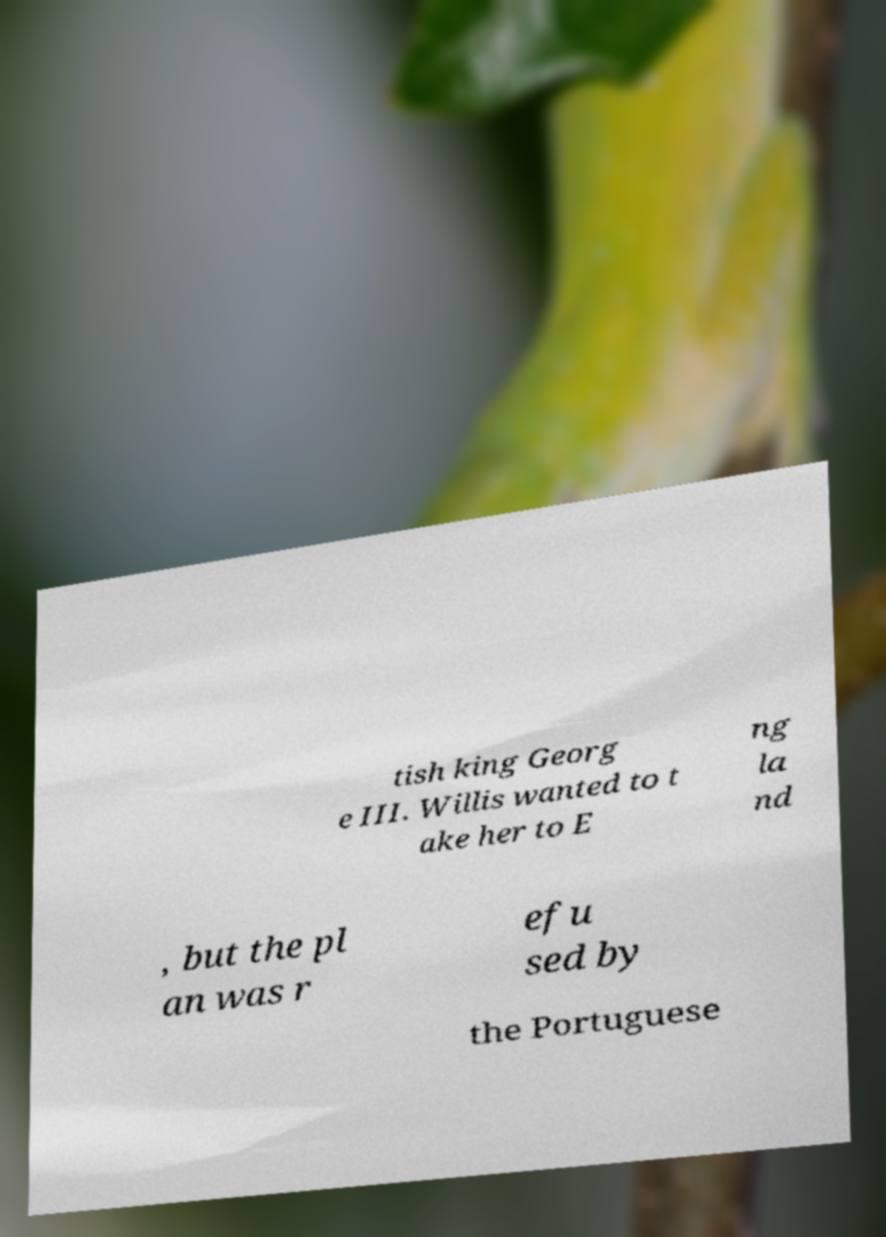Can you accurately transcribe the text from the provided image for me? tish king Georg e III. Willis wanted to t ake her to E ng la nd , but the pl an was r efu sed by the Portuguese 